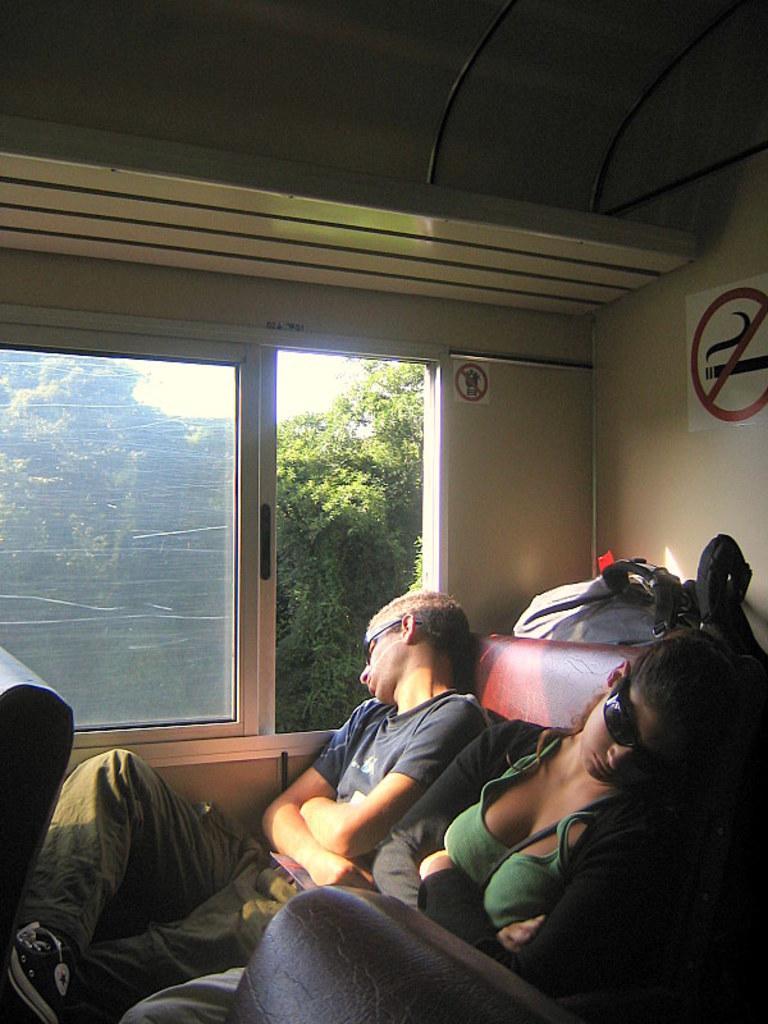Please provide a concise description of this image. This image is taken in a vehicle. At the bottom of the image there is a seat. In the middle of the image a girl and a boy are sitting on the seat and there is a luggage and there is a signboard. There is a window and through the window we can see there are a few trees. 